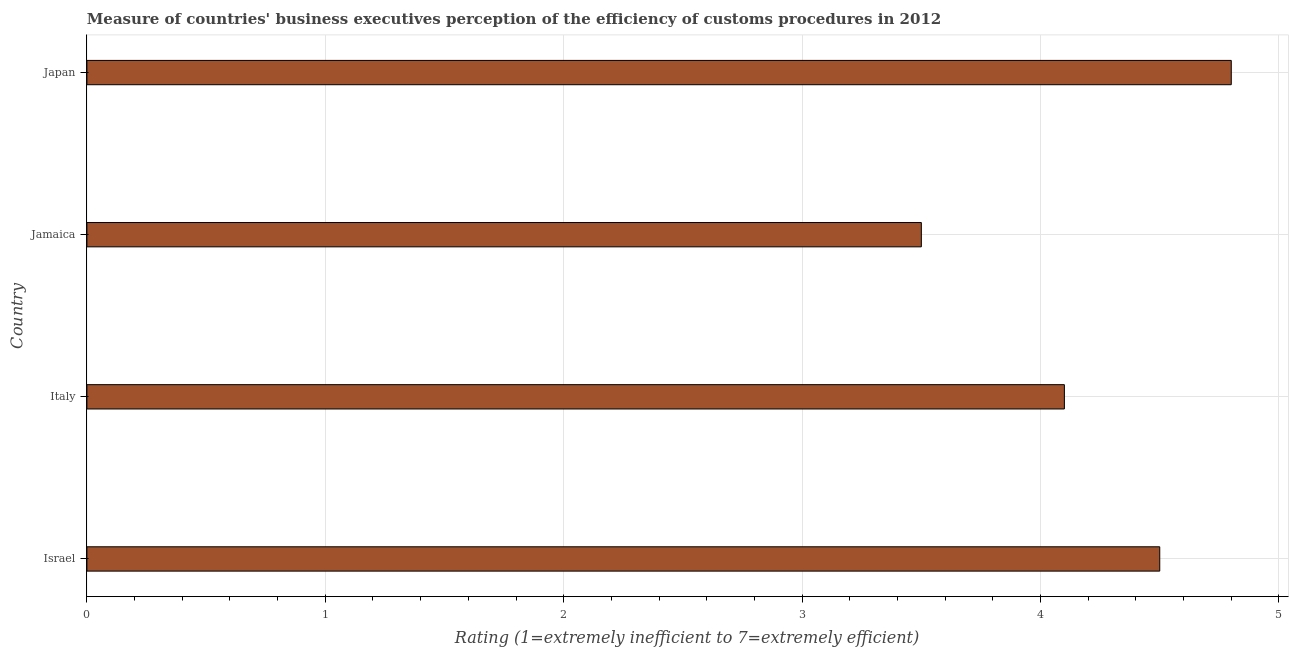Does the graph contain grids?
Keep it short and to the point. Yes. What is the title of the graph?
Make the answer very short. Measure of countries' business executives perception of the efficiency of customs procedures in 2012. What is the label or title of the X-axis?
Provide a succinct answer. Rating (1=extremely inefficient to 7=extremely efficient). What is the rating measuring burden of customs procedure in Israel?
Make the answer very short. 4.5. Across all countries, what is the maximum rating measuring burden of customs procedure?
Offer a very short reply. 4.8. Across all countries, what is the minimum rating measuring burden of customs procedure?
Your answer should be compact. 3.5. In which country was the rating measuring burden of customs procedure maximum?
Your answer should be compact. Japan. In which country was the rating measuring burden of customs procedure minimum?
Provide a succinct answer. Jamaica. What is the sum of the rating measuring burden of customs procedure?
Give a very brief answer. 16.9. What is the difference between the rating measuring burden of customs procedure in Israel and Japan?
Provide a succinct answer. -0.3. What is the average rating measuring burden of customs procedure per country?
Keep it short and to the point. 4.22. What is the median rating measuring burden of customs procedure?
Offer a very short reply. 4.3. In how many countries, is the rating measuring burden of customs procedure greater than 4.6 ?
Give a very brief answer. 1. What is the ratio of the rating measuring burden of customs procedure in Italy to that in Jamaica?
Your answer should be compact. 1.17. Are all the bars in the graph horizontal?
Keep it short and to the point. Yes. What is the difference between two consecutive major ticks on the X-axis?
Keep it short and to the point. 1. Are the values on the major ticks of X-axis written in scientific E-notation?
Give a very brief answer. No. What is the Rating (1=extremely inefficient to 7=extremely efficient) of Israel?
Ensure brevity in your answer.  4.5. What is the difference between the Rating (1=extremely inefficient to 7=extremely efficient) in Israel and Italy?
Ensure brevity in your answer.  0.4. What is the difference between the Rating (1=extremely inefficient to 7=extremely efficient) in Israel and Jamaica?
Make the answer very short. 1. What is the difference between the Rating (1=extremely inefficient to 7=extremely efficient) in Israel and Japan?
Provide a short and direct response. -0.3. What is the difference between the Rating (1=extremely inefficient to 7=extremely efficient) in Italy and Jamaica?
Your answer should be compact. 0.6. What is the ratio of the Rating (1=extremely inefficient to 7=extremely efficient) in Israel to that in Italy?
Keep it short and to the point. 1.1. What is the ratio of the Rating (1=extremely inefficient to 7=extremely efficient) in Israel to that in Jamaica?
Your response must be concise. 1.29. What is the ratio of the Rating (1=extremely inefficient to 7=extremely efficient) in Israel to that in Japan?
Offer a terse response. 0.94. What is the ratio of the Rating (1=extremely inefficient to 7=extremely efficient) in Italy to that in Jamaica?
Keep it short and to the point. 1.17. What is the ratio of the Rating (1=extremely inefficient to 7=extremely efficient) in Italy to that in Japan?
Keep it short and to the point. 0.85. What is the ratio of the Rating (1=extremely inefficient to 7=extremely efficient) in Jamaica to that in Japan?
Your answer should be compact. 0.73. 